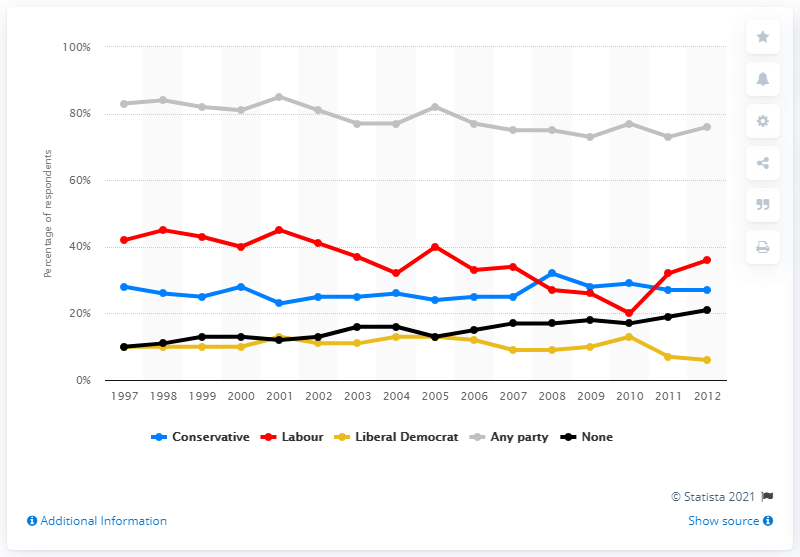Indicate a few pertinent items in this graphic. In 2012, the Labour party had the most people who identified with them. 